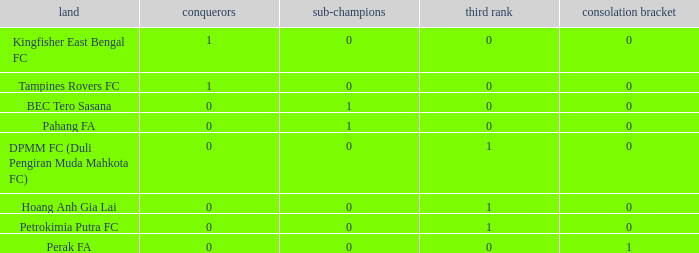Name the highest 3rd place for nation of perak fa 0.0. 